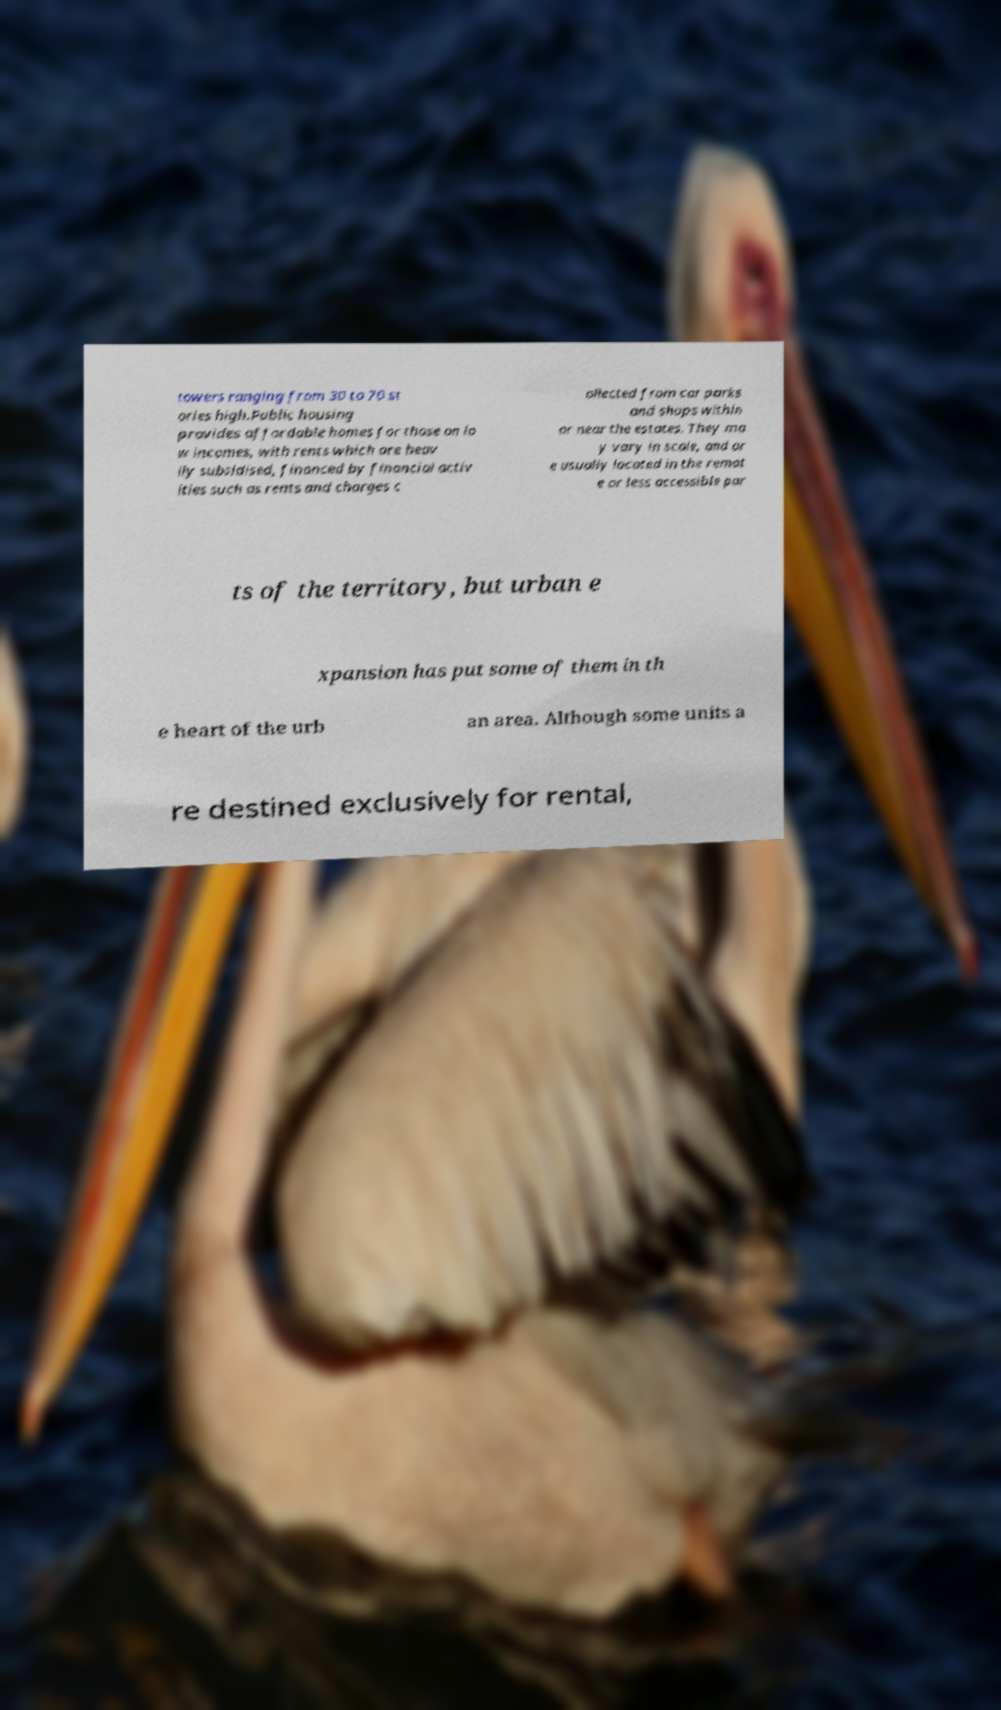For documentation purposes, I need the text within this image transcribed. Could you provide that? towers ranging from 30 to 70 st ories high.Public housing provides affordable homes for those on lo w incomes, with rents which are heav ily subsidised, financed by financial activ ities such as rents and charges c ollected from car parks and shops within or near the estates. They ma y vary in scale, and ar e usually located in the remot e or less accessible par ts of the territory, but urban e xpansion has put some of them in th e heart of the urb an area. Although some units a re destined exclusively for rental, 